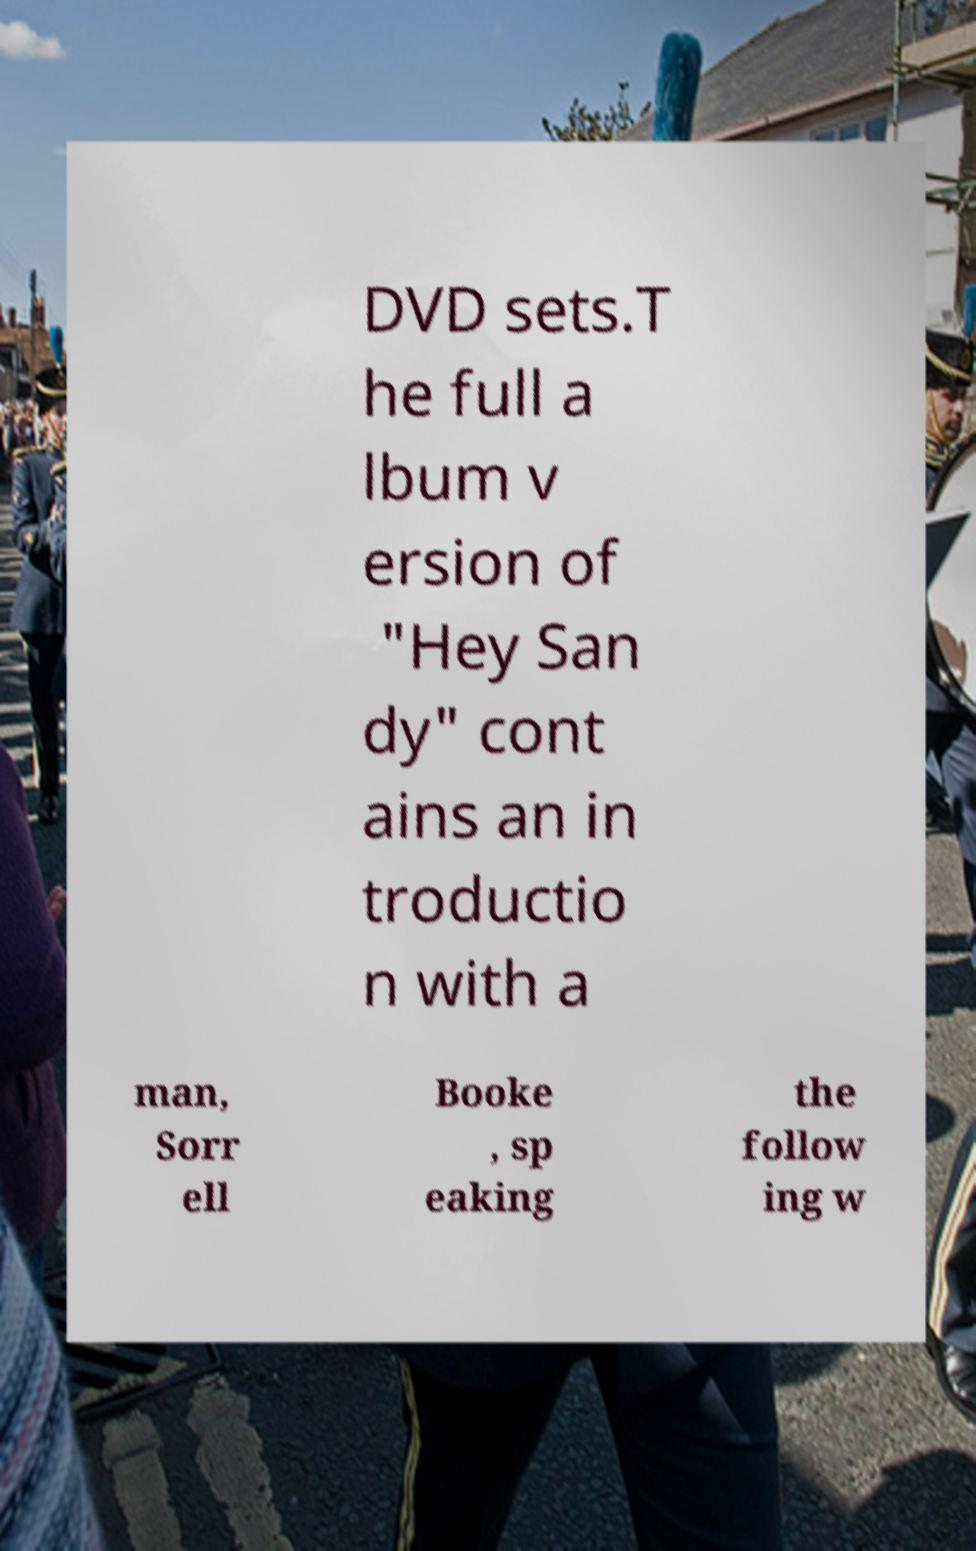Can you read and provide the text displayed in the image?This photo seems to have some interesting text. Can you extract and type it out for me? DVD sets.T he full a lbum v ersion of "Hey San dy" cont ains an in troductio n with a man, Sorr ell Booke , sp eaking the follow ing w 